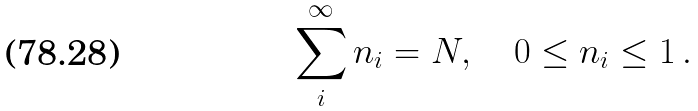<formula> <loc_0><loc_0><loc_500><loc_500>\sum _ { i } ^ { \infty } n _ { i } = N , \quad 0 \leq n _ { i } \leq 1 \, .</formula> 